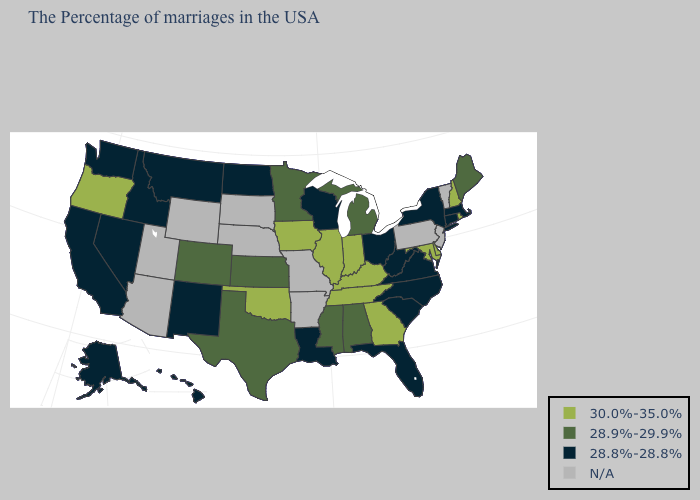What is the highest value in the USA?
Answer briefly. 30.0%-35.0%. What is the value of Pennsylvania?
Write a very short answer. N/A. Name the states that have a value in the range 30.0%-35.0%?
Be succinct. Rhode Island, New Hampshire, Delaware, Maryland, Georgia, Kentucky, Indiana, Tennessee, Illinois, Iowa, Oklahoma, Oregon. Name the states that have a value in the range 30.0%-35.0%?
Be succinct. Rhode Island, New Hampshire, Delaware, Maryland, Georgia, Kentucky, Indiana, Tennessee, Illinois, Iowa, Oklahoma, Oregon. What is the highest value in the USA?
Answer briefly. 30.0%-35.0%. What is the value of Oregon?
Concise answer only. 30.0%-35.0%. What is the value of Connecticut?
Be succinct. 28.8%-28.8%. Does Illinois have the highest value in the MidWest?
Keep it brief. Yes. Which states have the lowest value in the MidWest?
Keep it brief. Ohio, Wisconsin, North Dakota. Name the states that have a value in the range 28.8%-28.8%?
Answer briefly. Massachusetts, Connecticut, New York, Virginia, North Carolina, South Carolina, West Virginia, Ohio, Florida, Wisconsin, Louisiana, North Dakota, New Mexico, Montana, Idaho, Nevada, California, Washington, Alaska, Hawaii. Name the states that have a value in the range N/A?
Concise answer only. Vermont, New Jersey, Pennsylvania, Missouri, Arkansas, Nebraska, South Dakota, Wyoming, Utah, Arizona. Does Alaska have the highest value in the USA?
Be succinct. No. Name the states that have a value in the range 28.8%-28.8%?
Concise answer only. Massachusetts, Connecticut, New York, Virginia, North Carolina, South Carolina, West Virginia, Ohio, Florida, Wisconsin, Louisiana, North Dakota, New Mexico, Montana, Idaho, Nevada, California, Washington, Alaska, Hawaii. 